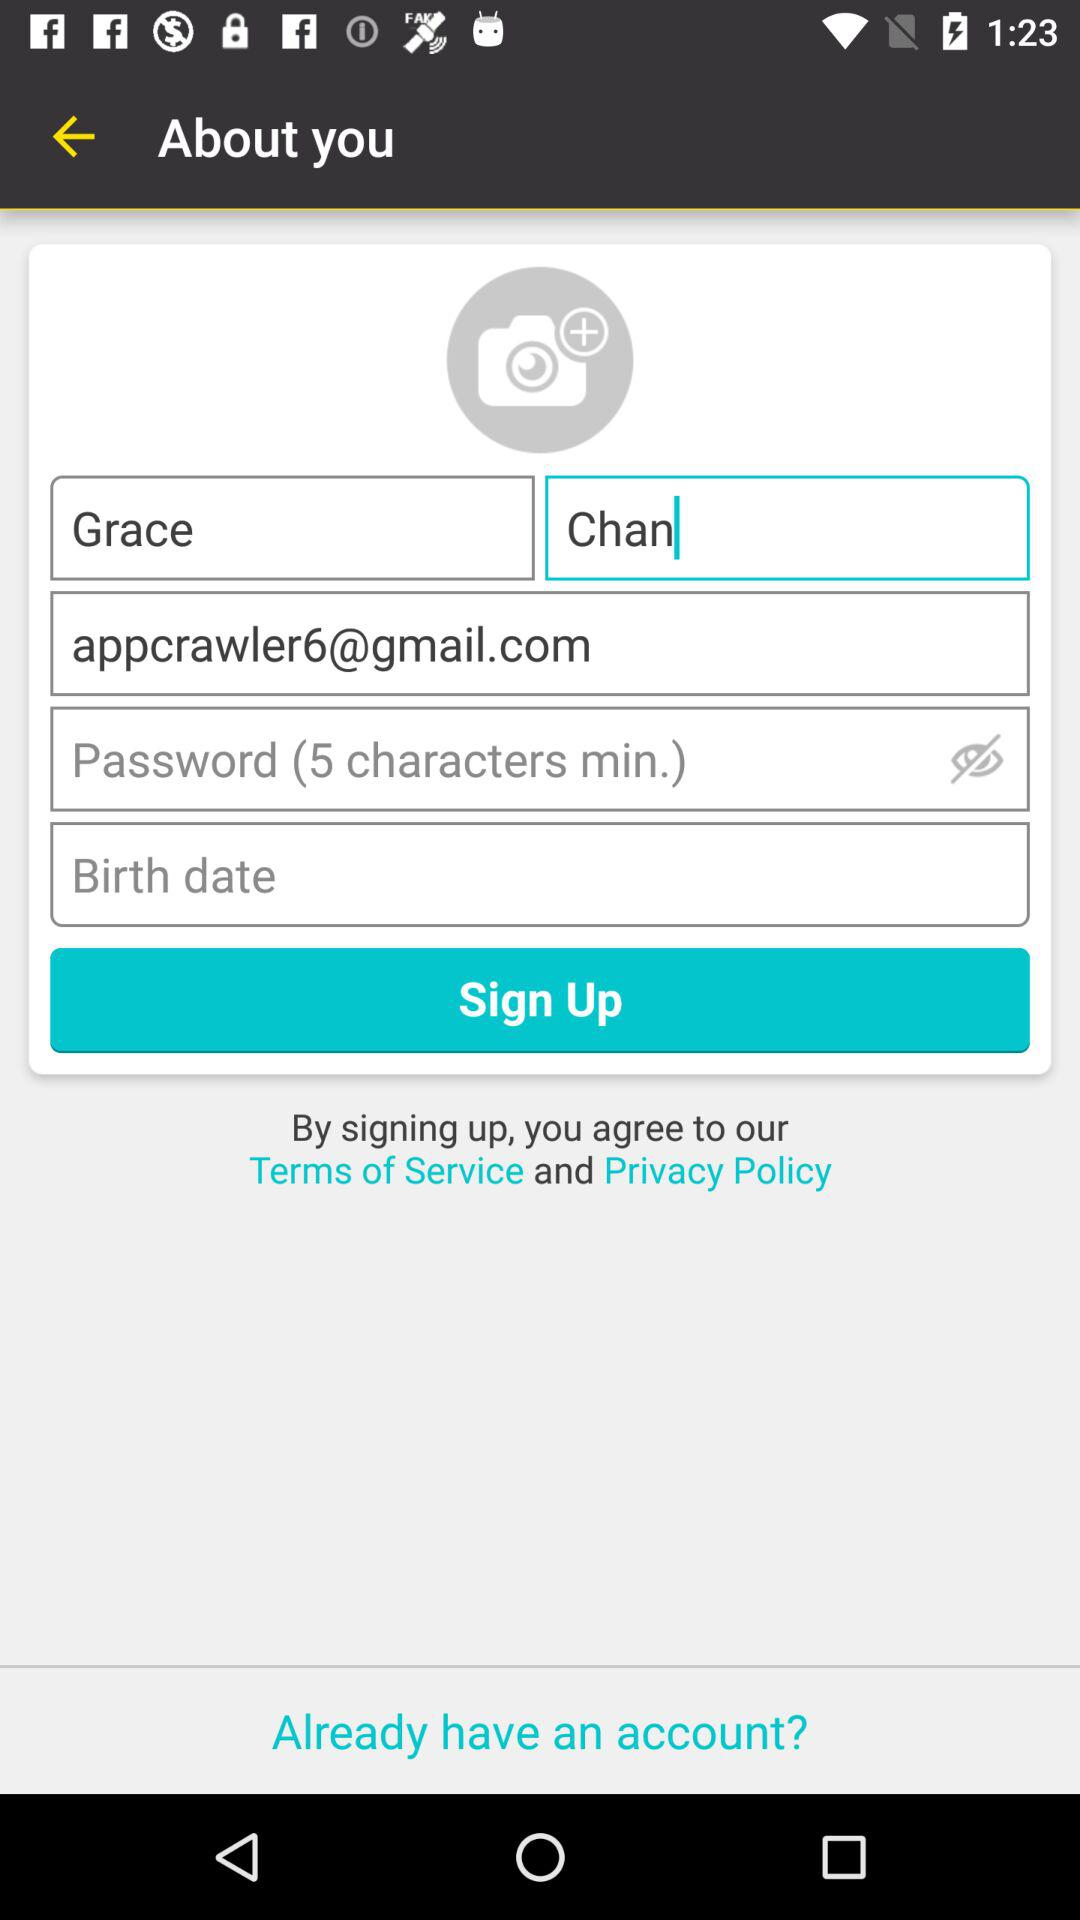What is the email address of Grace? The email address is appcrawler6@gmail.com. 